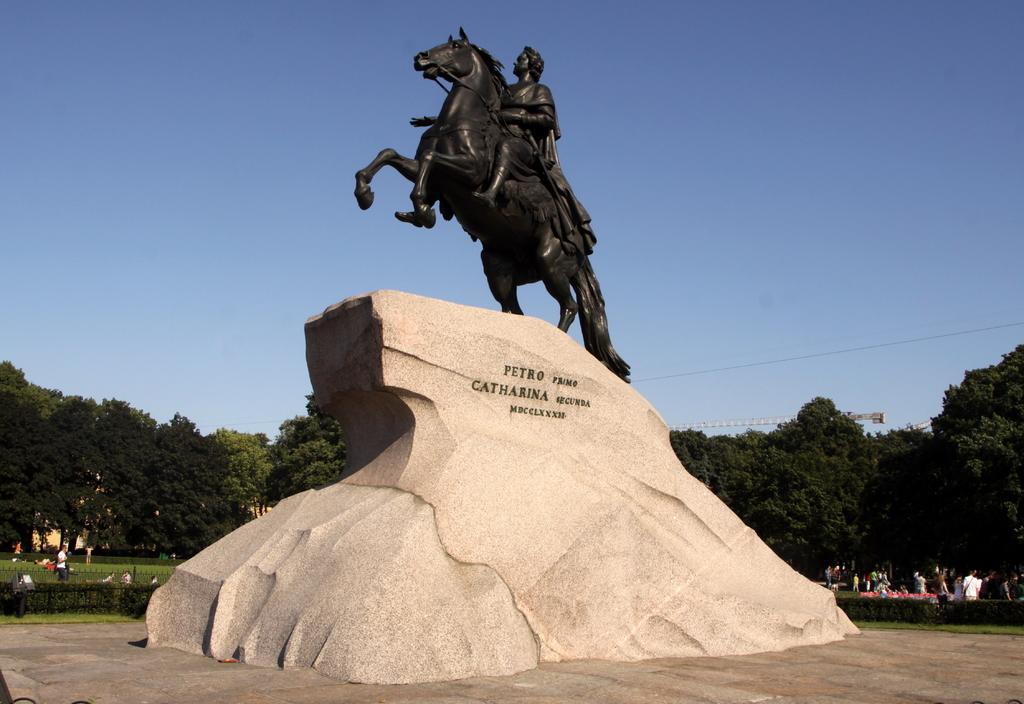What is the main subject of the image? There is a statue on a stone in the image. What is written or engraved on the stone? There is text on the stone. What can be seen in the background of the image? There are people, trees, and the sky visible in the background of the image. Where is the coat rack located in the image? There is no coat rack present in the image. What type of books can be found in the library depicted in the image? There is no library depicted in the image. 